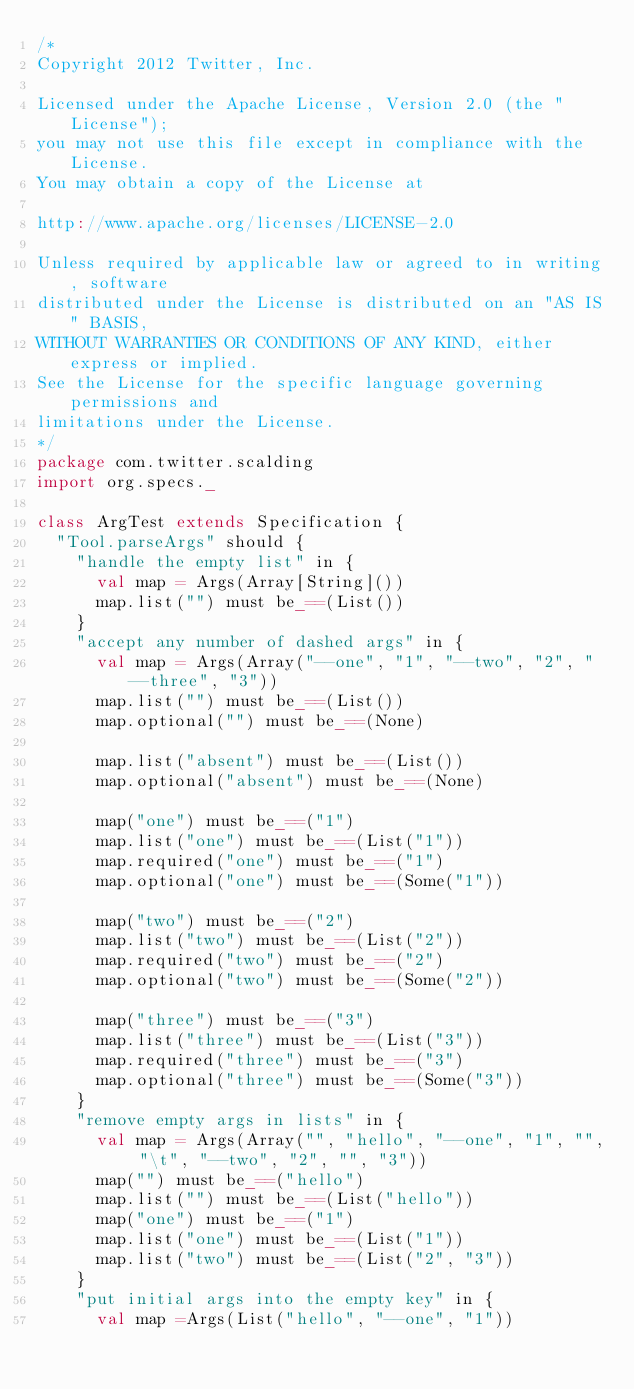<code> <loc_0><loc_0><loc_500><loc_500><_Scala_>/*
Copyright 2012 Twitter, Inc.

Licensed under the Apache License, Version 2.0 (the "License");
you may not use this file except in compliance with the License.
You may obtain a copy of the License at

http://www.apache.org/licenses/LICENSE-2.0

Unless required by applicable law or agreed to in writing, software
distributed under the License is distributed on an "AS IS" BASIS,
WITHOUT WARRANTIES OR CONDITIONS OF ANY KIND, either express or implied.
See the License for the specific language governing permissions and
limitations under the License.
*/
package com.twitter.scalding
import org.specs._

class ArgTest extends Specification {
  "Tool.parseArgs" should {
    "handle the empty list" in {
      val map = Args(Array[String]())
      map.list("") must be_==(List())
    }
    "accept any number of dashed args" in {
      val map = Args(Array("--one", "1", "--two", "2", "--three", "3"))
      map.list("") must be_==(List())
      map.optional("") must be_==(None)

      map.list("absent") must be_==(List())
      map.optional("absent") must be_==(None)

      map("one") must be_==("1")
      map.list("one") must be_==(List("1"))
      map.required("one") must be_==("1")
      map.optional("one") must be_==(Some("1"))

      map("two") must be_==("2")
      map.list("two") must be_==(List("2"))
      map.required("two") must be_==("2")
      map.optional("two") must be_==(Some("2"))

      map("three") must be_==("3")
      map.list("three") must be_==(List("3"))
      map.required("three") must be_==("3")
      map.optional("three") must be_==(Some("3"))
    }
    "remove empty args in lists" in {
      val map = Args(Array("", "hello", "--one", "1", "", "\t", "--two", "2", "", "3"))
      map("") must be_==("hello")
      map.list("") must be_==(List("hello"))
      map("one") must be_==("1")
      map.list("one") must be_==(List("1"))
      map.list("two") must be_==(List("2", "3"))
    }
    "put initial args into the empty key" in {
      val map =Args(List("hello", "--one", "1"))</code> 